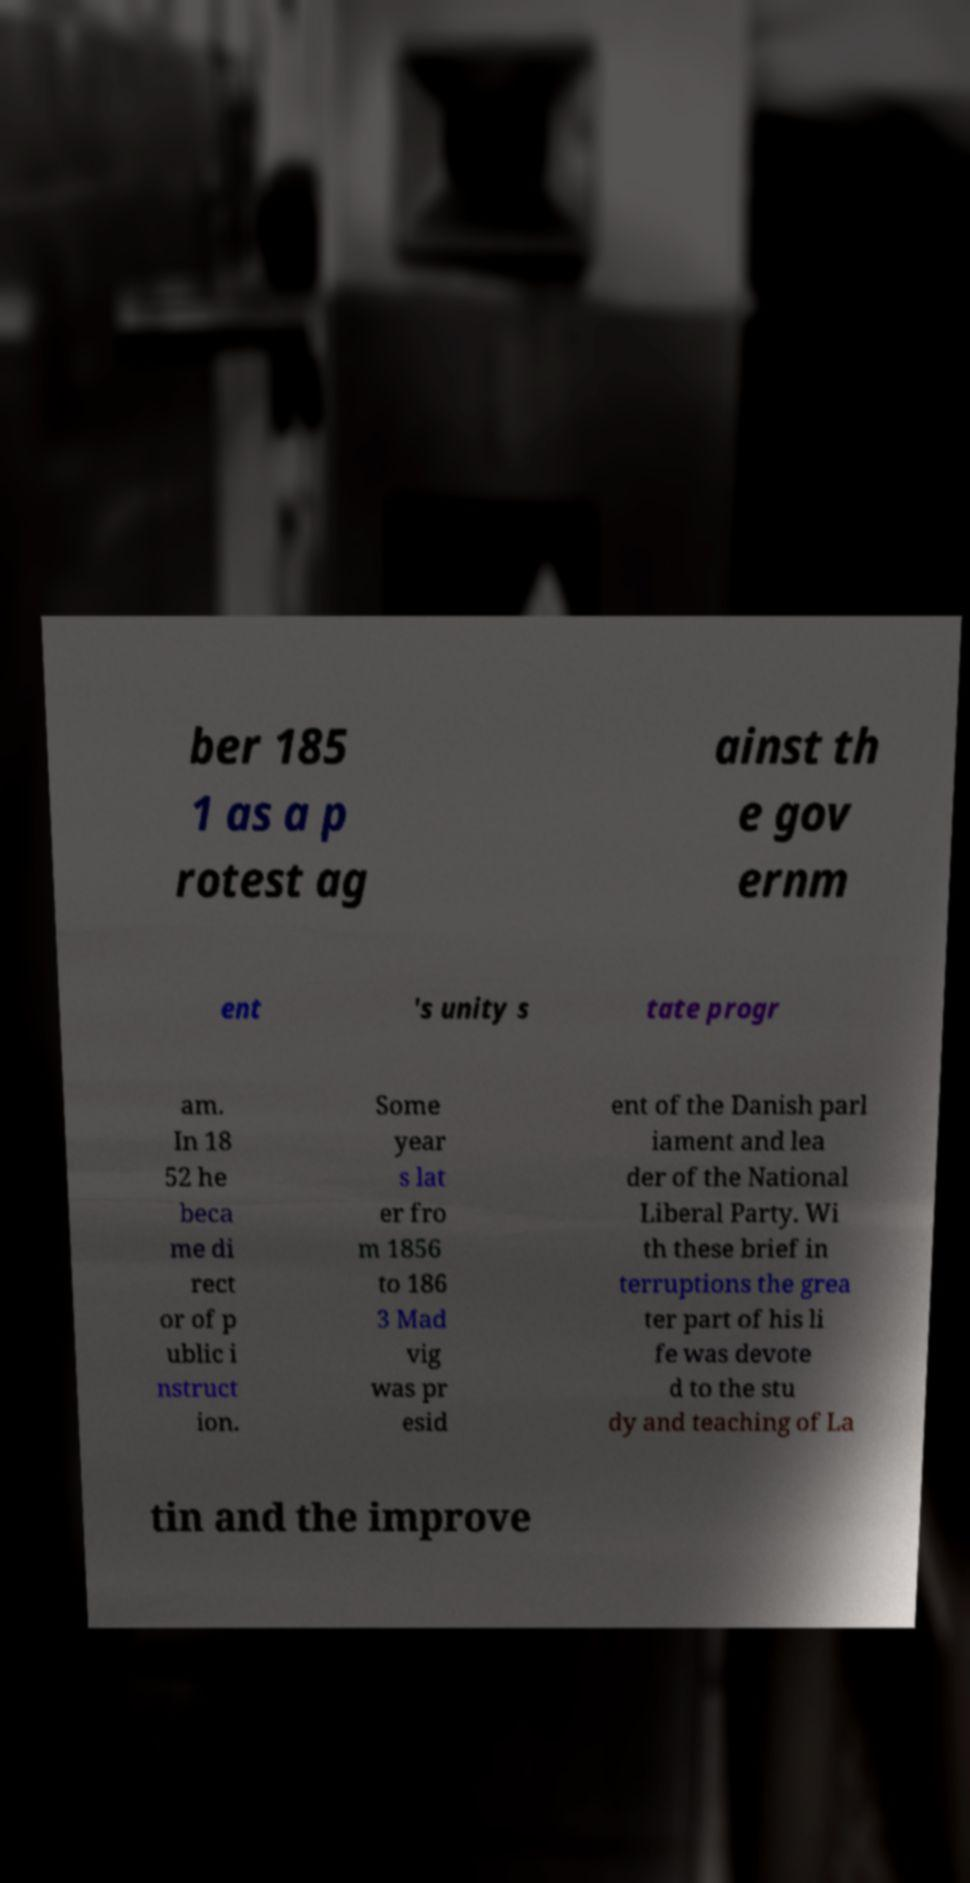Can you read and provide the text displayed in the image?This photo seems to have some interesting text. Can you extract and type it out for me? ber 185 1 as a p rotest ag ainst th e gov ernm ent 's unity s tate progr am. In 18 52 he beca me di rect or of p ublic i nstruct ion. Some year s lat er fro m 1856 to 186 3 Mad vig was pr esid ent of the Danish parl iament and lea der of the National Liberal Party. Wi th these brief in terruptions the grea ter part of his li fe was devote d to the stu dy and teaching of La tin and the improve 